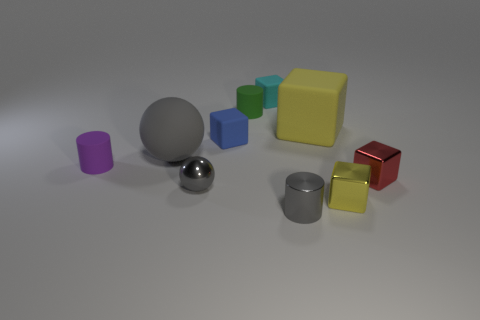There is a gray sphere that is the same size as the red shiny thing; what is its material?
Make the answer very short. Metal. Is there a small green cylinder that has the same material as the blue cube?
Offer a terse response. Yes. What number of purple rubber cylinders are there?
Provide a short and direct response. 1. Are the small gray sphere and the small cylinder that is in front of the small purple cylinder made of the same material?
Keep it short and to the point. Yes. There is a tiny sphere that is the same color as the big rubber ball; what is its material?
Your answer should be compact. Metal. How many small objects are the same color as the big sphere?
Provide a succinct answer. 2. The yellow rubber cube is what size?
Give a very brief answer. Large. There is a cyan matte thing; is its shape the same as the metal object that is to the right of the yellow metallic object?
Give a very brief answer. Yes. There is a ball that is the same material as the tiny red object; what color is it?
Provide a succinct answer. Gray. What size is the yellow block on the right side of the large yellow matte cube?
Your answer should be very brief. Small. 